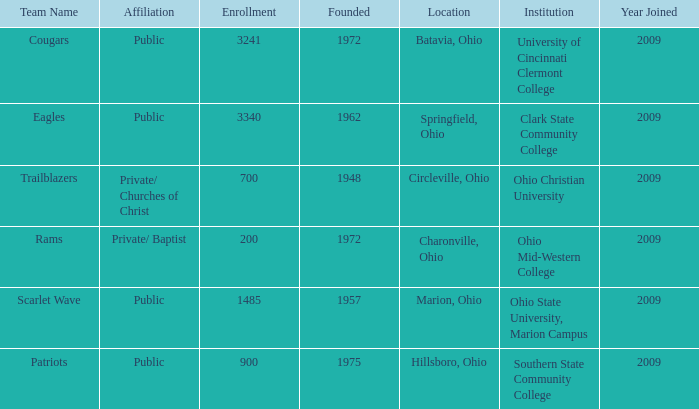What is the location when founded was 1957? Marion, Ohio. 